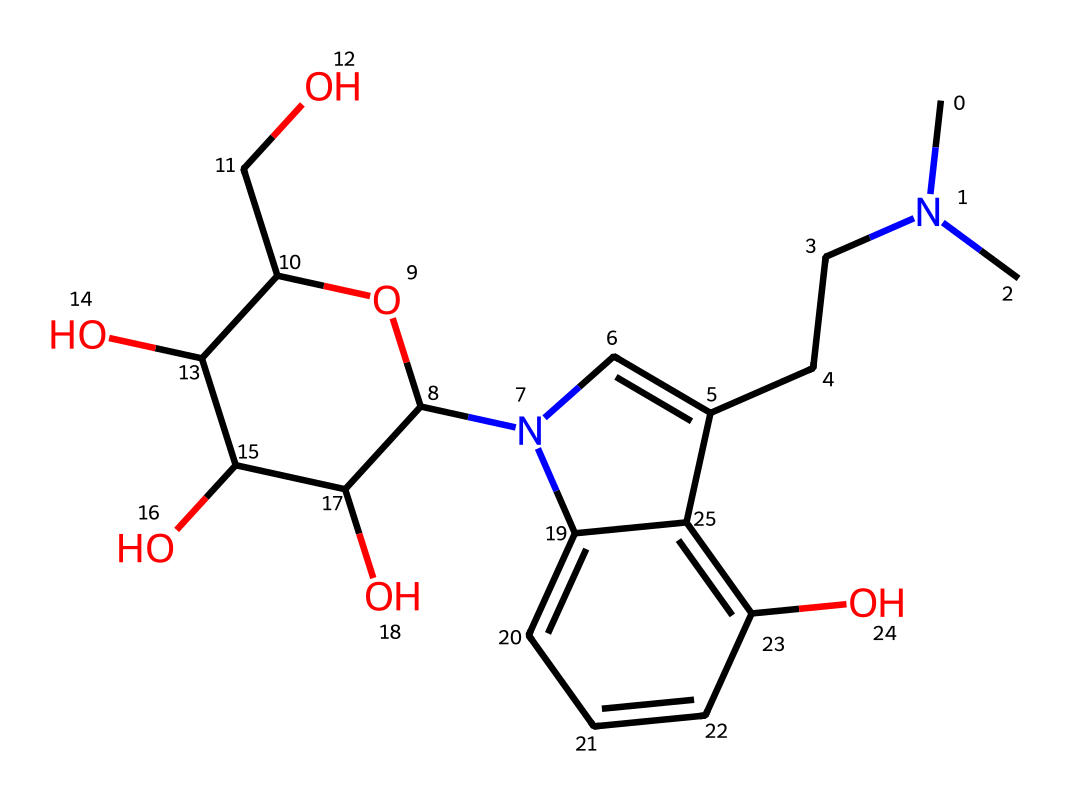What is the molecular formula of psilocybin? By analyzing the SMILES representation, we can determine the count of each type of atom. The representation indicates the presence of carbon (C), hydrogen (H), oxygen (O), and nitrogen (N) atoms, which can be tallied to provide the molecular formula.
Answer: C12H17N2O4P How many nitrogen atoms are in the structure? The SMILES representation includes two 'N' symbols, indicating the presence of two nitrogen atoms in the chemical structure.
Answer: 2 What type of alkaloid does this compound represent? The presence of the tryptamine structure, indicated by the indole ring and nitrogen, identifies this compound as a tryptamine alkaloid, which is characteristic of psilocybin.
Answer: tryptamine Does this compound contain an ether group? The SMILES notation includes 'OC', which signifies a connection between an oxygen atom and a carbon atom, indicating that this compound has an ether functional group.
Answer: yes What is the significance of the phosphate group in psilocybin? The phosphate (P) group is integral to psilocybin as it plays a crucial role in its function and metabolism in biological systems, particularly in neuroplasticity research, by enabling phosphorylation.
Answer: crucial role What is the role of hydroxyl groups in this compound? The chemical structure shows multiple 'O' atoms bonded to hydrogen, which indicates the presence of hydroxyl groups (–OH). These groups significantly influence the compound's polarity and solubility in water, affecting its biological activity.
Answer: influence polarity How does the structure of psilocybin potentially enhance neuroplasticity? The structure of psilocybin, particularly its alkaloid nature and receptor binding affinity, suggests that it may facilitate neuroplasticity by promoting synaptic changes through interaction with serotonin receptors, which are involved in mood regulation and cognitive functions.
Answer: promote synaptic changes 